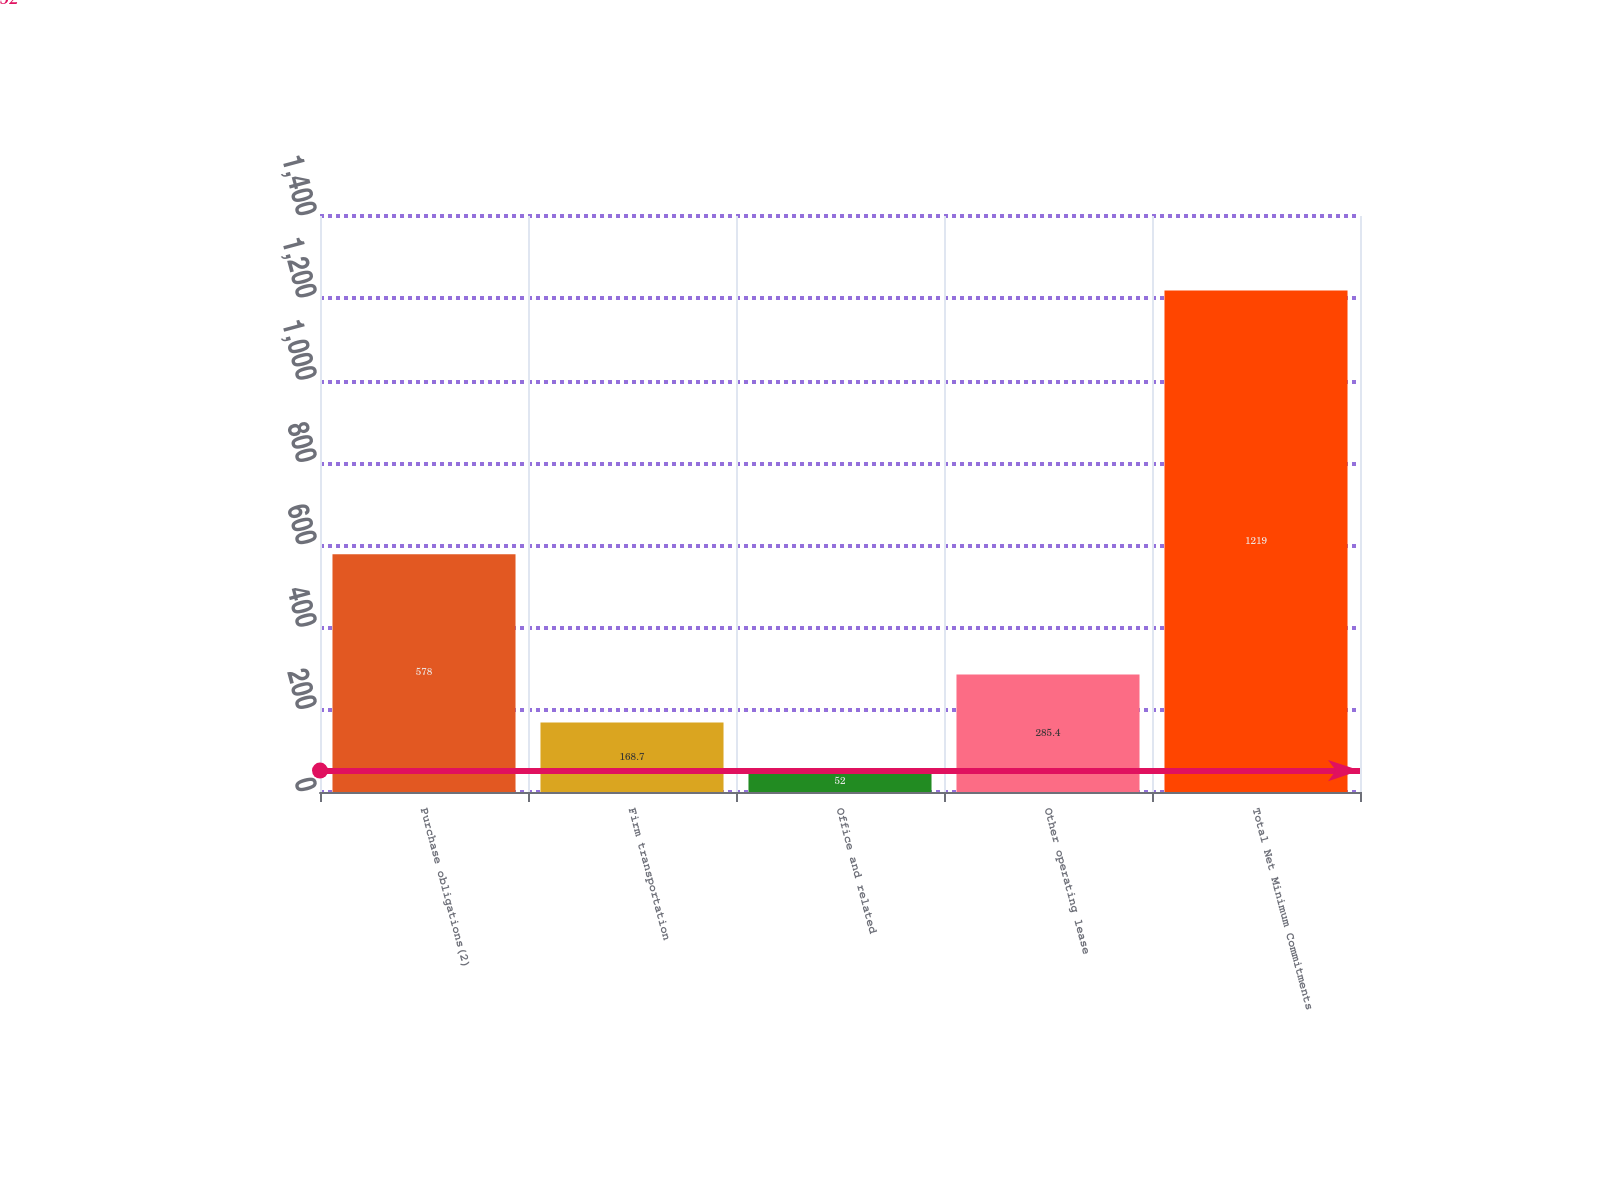Convert chart. <chart><loc_0><loc_0><loc_500><loc_500><bar_chart><fcel>Purchase obligations(2)<fcel>Firm transportation<fcel>Office and related<fcel>Other operating lease<fcel>Total Net Minimum Commitments<nl><fcel>578<fcel>168.7<fcel>52<fcel>285.4<fcel>1219<nl></chart> 